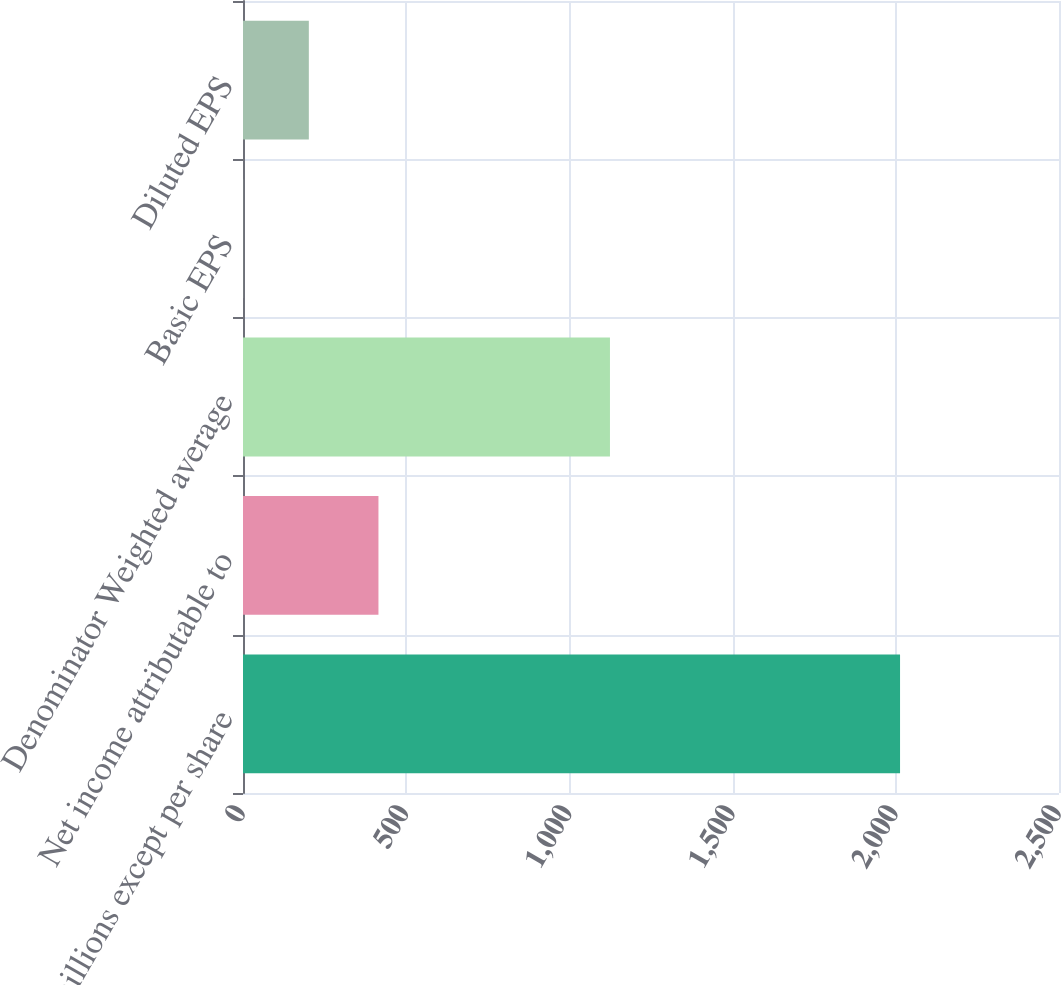Convert chart. <chart><loc_0><loc_0><loc_500><loc_500><bar_chart><fcel>(in millions except per share<fcel>Net income attributable to<fcel>Denominator Weighted average<fcel>Basic EPS<fcel>Diluted EPS<nl><fcel>2013<fcel>415<fcel>1124.26<fcel>0.45<fcel>201.7<nl></chart> 